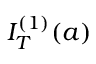<formula> <loc_0><loc_0><loc_500><loc_500>I _ { T } ^ { ( 1 ) } ( a )</formula> 